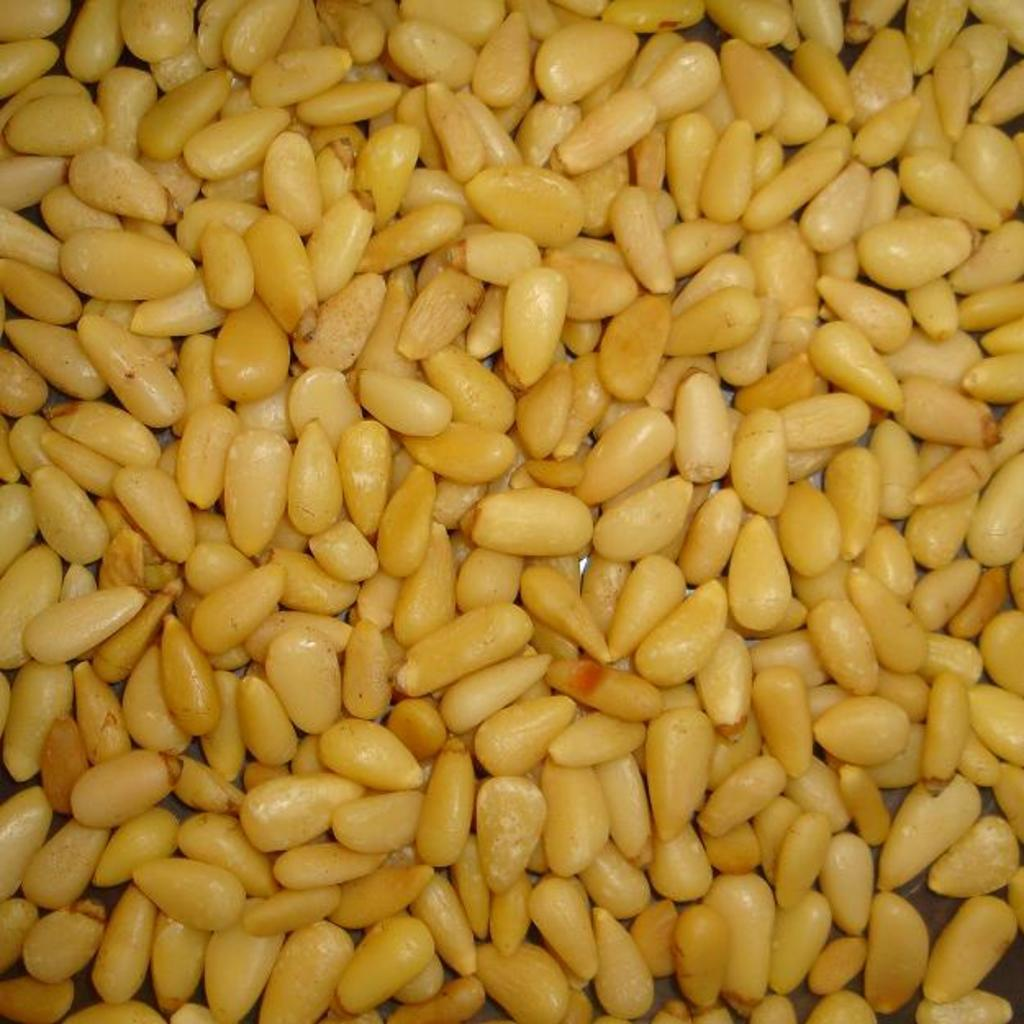What type of food is visible in the image? There are corn kernels in the image. What color are the corn kernels? The corn kernels are yellow in color. How many balloons are floating in the image? There are no balloons present in the image. What type of insect can be seen flying near the corn kernels in the image? There are no insects visible in the image, and therefore no such activity can be observed. 